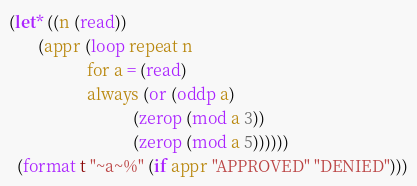<code> <loc_0><loc_0><loc_500><loc_500><_Lisp_>(let* ((n (read))
       (appr (loop repeat n
                   for a = (read)
                   always (or (oddp a)
                              (zerop (mod a 3))
                              (zerop (mod a 5))))))
  (format t "~a~%" (if appr "APPROVED" "DENIED")))</code> 